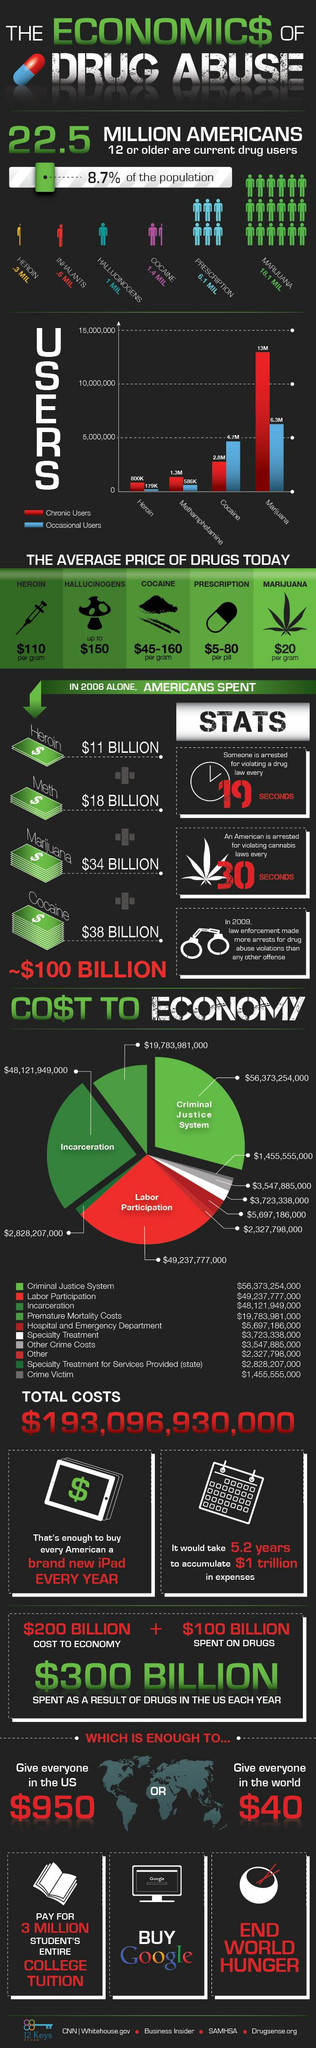Draw attention to some important aspects in this diagram. A recent survey found that 27.11% of Americans use prescription drugs. Heroin, cocaine, and marijuana are drugs that are commonly used. Among these drugs, cocaine is considered the most expensive. In fact, it is more expensive than heroin and marijuana. Approximately 2.8 million people in the United States are chronic users of cocaine, according to recent estimates. According to data, there are significantly more chronic users of Heroin (621K) than occasional users (24K). According to statistics, approximately 6.3 million people use marijuana occasionally. 